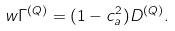<formula> <loc_0><loc_0><loc_500><loc_500>w \Gamma ^ { ( Q ) } = ( 1 - c ^ { 2 } _ { a } ) D ^ { ( Q ) } .</formula> 